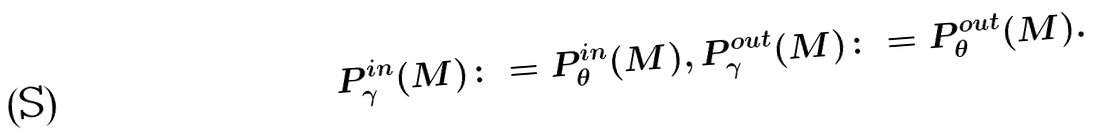<formula> <loc_0><loc_0><loc_500><loc_500>P _ { \gamma } ^ { i n } ( M ) \colon = P _ { \theta } ^ { i n } ( M ) , \, P _ { \gamma } ^ { o u t } ( M ) \colon = P _ { \theta } ^ { o u t } ( M ) .</formula> 